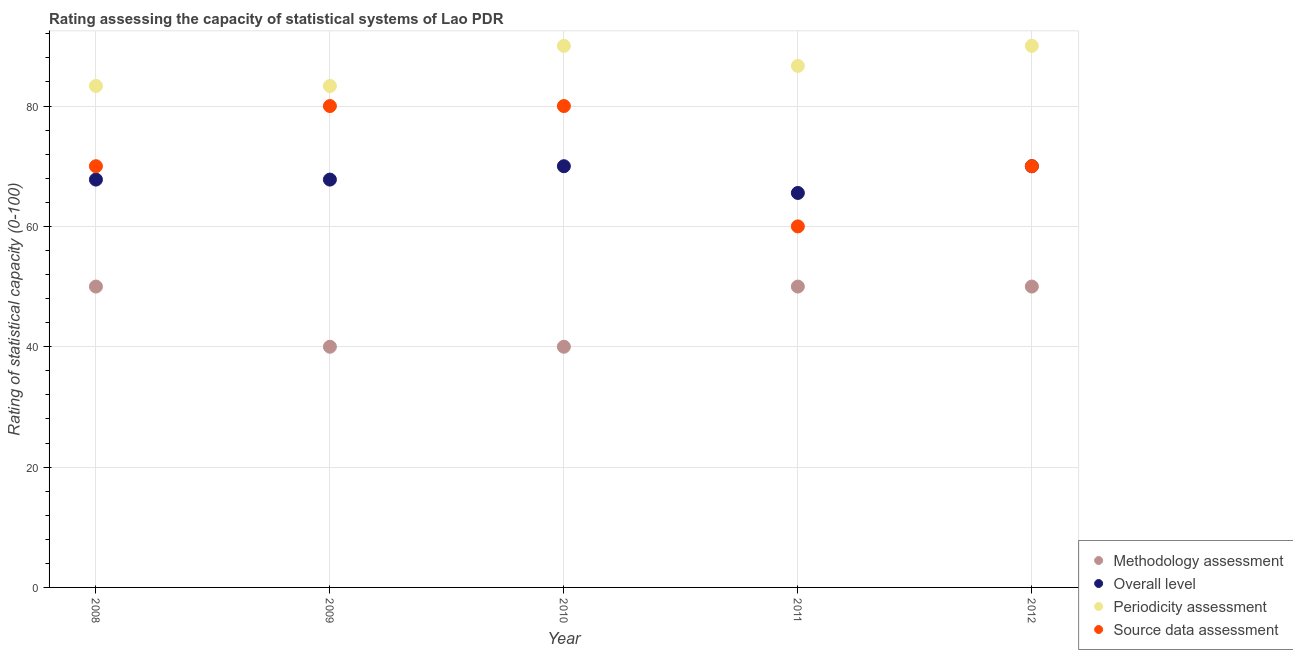How many different coloured dotlines are there?
Your answer should be compact. 4. What is the methodology assessment rating in 2012?
Provide a short and direct response. 50. Across all years, what is the maximum methodology assessment rating?
Provide a short and direct response. 50. Across all years, what is the minimum source data assessment rating?
Make the answer very short. 60. In which year was the periodicity assessment rating maximum?
Keep it short and to the point. 2010. In which year was the source data assessment rating minimum?
Keep it short and to the point. 2011. What is the total source data assessment rating in the graph?
Your answer should be compact. 360. What is the difference between the methodology assessment rating in 2011 and that in 2012?
Keep it short and to the point. 0. What is the average methodology assessment rating per year?
Your answer should be very brief. 46. In the year 2011, what is the difference between the periodicity assessment rating and methodology assessment rating?
Give a very brief answer. 36.67. What is the ratio of the periodicity assessment rating in 2009 to that in 2010?
Offer a terse response. 0.93. What is the difference between the highest and the second highest source data assessment rating?
Offer a very short reply. 0. What is the difference between the highest and the lowest periodicity assessment rating?
Your response must be concise. 6.67. In how many years, is the methodology assessment rating greater than the average methodology assessment rating taken over all years?
Make the answer very short. 3. Is the sum of the periodicity assessment rating in 2009 and 2011 greater than the maximum source data assessment rating across all years?
Offer a very short reply. Yes. Is it the case that in every year, the sum of the periodicity assessment rating and overall level rating is greater than the sum of source data assessment rating and methodology assessment rating?
Keep it short and to the point. No. Is it the case that in every year, the sum of the methodology assessment rating and overall level rating is greater than the periodicity assessment rating?
Give a very brief answer. Yes. Does the overall level rating monotonically increase over the years?
Offer a very short reply. No. Is the source data assessment rating strictly greater than the methodology assessment rating over the years?
Give a very brief answer. Yes. Is the methodology assessment rating strictly less than the overall level rating over the years?
Ensure brevity in your answer.  Yes. How many years are there in the graph?
Your response must be concise. 5. What is the difference between two consecutive major ticks on the Y-axis?
Provide a succinct answer. 20. Does the graph contain any zero values?
Your answer should be very brief. No. Does the graph contain grids?
Your answer should be very brief. Yes. How many legend labels are there?
Give a very brief answer. 4. How are the legend labels stacked?
Your answer should be very brief. Vertical. What is the title of the graph?
Keep it short and to the point. Rating assessing the capacity of statistical systems of Lao PDR. Does "Natural Gas" appear as one of the legend labels in the graph?
Keep it short and to the point. No. What is the label or title of the Y-axis?
Ensure brevity in your answer.  Rating of statistical capacity (0-100). What is the Rating of statistical capacity (0-100) of Methodology assessment in 2008?
Your answer should be compact. 50. What is the Rating of statistical capacity (0-100) of Overall level in 2008?
Provide a short and direct response. 67.78. What is the Rating of statistical capacity (0-100) in Periodicity assessment in 2008?
Keep it short and to the point. 83.33. What is the Rating of statistical capacity (0-100) of Methodology assessment in 2009?
Make the answer very short. 40. What is the Rating of statistical capacity (0-100) of Overall level in 2009?
Offer a terse response. 67.78. What is the Rating of statistical capacity (0-100) of Periodicity assessment in 2009?
Give a very brief answer. 83.33. What is the Rating of statistical capacity (0-100) in Source data assessment in 2009?
Your answer should be compact. 80. What is the Rating of statistical capacity (0-100) of Periodicity assessment in 2010?
Provide a short and direct response. 90. What is the Rating of statistical capacity (0-100) of Source data assessment in 2010?
Your answer should be very brief. 80. What is the Rating of statistical capacity (0-100) in Overall level in 2011?
Make the answer very short. 65.56. What is the Rating of statistical capacity (0-100) in Periodicity assessment in 2011?
Your answer should be very brief. 86.67. What is the Rating of statistical capacity (0-100) of Source data assessment in 2011?
Your answer should be very brief. 60. What is the Rating of statistical capacity (0-100) in Methodology assessment in 2012?
Your response must be concise. 50. What is the Rating of statistical capacity (0-100) of Overall level in 2012?
Give a very brief answer. 70. What is the Rating of statistical capacity (0-100) in Periodicity assessment in 2012?
Provide a short and direct response. 90. Across all years, what is the maximum Rating of statistical capacity (0-100) in Methodology assessment?
Your response must be concise. 50. Across all years, what is the maximum Rating of statistical capacity (0-100) of Overall level?
Your response must be concise. 70. Across all years, what is the maximum Rating of statistical capacity (0-100) in Periodicity assessment?
Provide a succinct answer. 90. Across all years, what is the maximum Rating of statistical capacity (0-100) of Source data assessment?
Make the answer very short. 80. Across all years, what is the minimum Rating of statistical capacity (0-100) of Overall level?
Offer a terse response. 65.56. Across all years, what is the minimum Rating of statistical capacity (0-100) in Periodicity assessment?
Keep it short and to the point. 83.33. What is the total Rating of statistical capacity (0-100) in Methodology assessment in the graph?
Your answer should be compact. 230. What is the total Rating of statistical capacity (0-100) in Overall level in the graph?
Offer a terse response. 341.11. What is the total Rating of statistical capacity (0-100) of Periodicity assessment in the graph?
Offer a very short reply. 433.33. What is the total Rating of statistical capacity (0-100) in Source data assessment in the graph?
Make the answer very short. 360. What is the difference between the Rating of statistical capacity (0-100) of Overall level in 2008 and that in 2009?
Offer a very short reply. 0. What is the difference between the Rating of statistical capacity (0-100) in Periodicity assessment in 2008 and that in 2009?
Provide a succinct answer. 0. What is the difference between the Rating of statistical capacity (0-100) of Methodology assessment in 2008 and that in 2010?
Offer a terse response. 10. What is the difference between the Rating of statistical capacity (0-100) in Overall level in 2008 and that in 2010?
Provide a succinct answer. -2.22. What is the difference between the Rating of statistical capacity (0-100) of Periodicity assessment in 2008 and that in 2010?
Offer a very short reply. -6.67. What is the difference between the Rating of statistical capacity (0-100) of Source data assessment in 2008 and that in 2010?
Provide a succinct answer. -10. What is the difference between the Rating of statistical capacity (0-100) in Methodology assessment in 2008 and that in 2011?
Offer a very short reply. 0. What is the difference between the Rating of statistical capacity (0-100) in Overall level in 2008 and that in 2011?
Provide a succinct answer. 2.22. What is the difference between the Rating of statistical capacity (0-100) of Periodicity assessment in 2008 and that in 2011?
Your response must be concise. -3.33. What is the difference between the Rating of statistical capacity (0-100) of Source data assessment in 2008 and that in 2011?
Your response must be concise. 10. What is the difference between the Rating of statistical capacity (0-100) of Overall level in 2008 and that in 2012?
Your answer should be compact. -2.22. What is the difference between the Rating of statistical capacity (0-100) in Periodicity assessment in 2008 and that in 2012?
Provide a short and direct response. -6.67. What is the difference between the Rating of statistical capacity (0-100) in Methodology assessment in 2009 and that in 2010?
Your response must be concise. 0. What is the difference between the Rating of statistical capacity (0-100) in Overall level in 2009 and that in 2010?
Your response must be concise. -2.22. What is the difference between the Rating of statistical capacity (0-100) in Periodicity assessment in 2009 and that in 2010?
Offer a terse response. -6.67. What is the difference between the Rating of statistical capacity (0-100) of Source data assessment in 2009 and that in 2010?
Your response must be concise. 0. What is the difference between the Rating of statistical capacity (0-100) of Overall level in 2009 and that in 2011?
Offer a very short reply. 2.22. What is the difference between the Rating of statistical capacity (0-100) in Source data assessment in 2009 and that in 2011?
Your response must be concise. 20. What is the difference between the Rating of statistical capacity (0-100) in Methodology assessment in 2009 and that in 2012?
Your answer should be very brief. -10. What is the difference between the Rating of statistical capacity (0-100) of Overall level in 2009 and that in 2012?
Your response must be concise. -2.22. What is the difference between the Rating of statistical capacity (0-100) in Periodicity assessment in 2009 and that in 2012?
Your answer should be very brief. -6.67. What is the difference between the Rating of statistical capacity (0-100) of Source data assessment in 2009 and that in 2012?
Keep it short and to the point. 10. What is the difference between the Rating of statistical capacity (0-100) of Methodology assessment in 2010 and that in 2011?
Provide a short and direct response. -10. What is the difference between the Rating of statistical capacity (0-100) in Overall level in 2010 and that in 2011?
Provide a succinct answer. 4.44. What is the difference between the Rating of statistical capacity (0-100) in Periodicity assessment in 2010 and that in 2011?
Offer a terse response. 3.33. What is the difference between the Rating of statistical capacity (0-100) in Source data assessment in 2010 and that in 2011?
Your answer should be compact. 20. What is the difference between the Rating of statistical capacity (0-100) of Methodology assessment in 2010 and that in 2012?
Make the answer very short. -10. What is the difference between the Rating of statistical capacity (0-100) in Periodicity assessment in 2010 and that in 2012?
Your response must be concise. 0. What is the difference between the Rating of statistical capacity (0-100) of Overall level in 2011 and that in 2012?
Make the answer very short. -4.44. What is the difference between the Rating of statistical capacity (0-100) in Periodicity assessment in 2011 and that in 2012?
Your response must be concise. -3.33. What is the difference between the Rating of statistical capacity (0-100) in Methodology assessment in 2008 and the Rating of statistical capacity (0-100) in Overall level in 2009?
Provide a succinct answer. -17.78. What is the difference between the Rating of statistical capacity (0-100) in Methodology assessment in 2008 and the Rating of statistical capacity (0-100) in Periodicity assessment in 2009?
Ensure brevity in your answer.  -33.33. What is the difference between the Rating of statistical capacity (0-100) of Methodology assessment in 2008 and the Rating of statistical capacity (0-100) of Source data assessment in 2009?
Your answer should be very brief. -30. What is the difference between the Rating of statistical capacity (0-100) in Overall level in 2008 and the Rating of statistical capacity (0-100) in Periodicity assessment in 2009?
Your answer should be compact. -15.56. What is the difference between the Rating of statistical capacity (0-100) in Overall level in 2008 and the Rating of statistical capacity (0-100) in Source data assessment in 2009?
Your answer should be very brief. -12.22. What is the difference between the Rating of statistical capacity (0-100) of Periodicity assessment in 2008 and the Rating of statistical capacity (0-100) of Source data assessment in 2009?
Your response must be concise. 3.33. What is the difference between the Rating of statistical capacity (0-100) in Methodology assessment in 2008 and the Rating of statistical capacity (0-100) in Periodicity assessment in 2010?
Provide a succinct answer. -40. What is the difference between the Rating of statistical capacity (0-100) in Methodology assessment in 2008 and the Rating of statistical capacity (0-100) in Source data assessment in 2010?
Make the answer very short. -30. What is the difference between the Rating of statistical capacity (0-100) of Overall level in 2008 and the Rating of statistical capacity (0-100) of Periodicity assessment in 2010?
Your answer should be compact. -22.22. What is the difference between the Rating of statistical capacity (0-100) in Overall level in 2008 and the Rating of statistical capacity (0-100) in Source data assessment in 2010?
Keep it short and to the point. -12.22. What is the difference between the Rating of statistical capacity (0-100) of Methodology assessment in 2008 and the Rating of statistical capacity (0-100) of Overall level in 2011?
Your response must be concise. -15.56. What is the difference between the Rating of statistical capacity (0-100) of Methodology assessment in 2008 and the Rating of statistical capacity (0-100) of Periodicity assessment in 2011?
Your response must be concise. -36.67. What is the difference between the Rating of statistical capacity (0-100) of Overall level in 2008 and the Rating of statistical capacity (0-100) of Periodicity assessment in 2011?
Your response must be concise. -18.89. What is the difference between the Rating of statistical capacity (0-100) in Overall level in 2008 and the Rating of statistical capacity (0-100) in Source data assessment in 2011?
Your response must be concise. 7.78. What is the difference between the Rating of statistical capacity (0-100) of Periodicity assessment in 2008 and the Rating of statistical capacity (0-100) of Source data assessment in 2011?
Your response must be concise. 23.33. What is the difference between the Rating of statistical capacity (0-100) in Methodology assessment in 2008 and the Rating of statistical capacity (0-100) in Overall level in 2012?
Provide a short and direct response. -20. What is the difference between the Rating of statistical capacity (0-100) of Overall level in 2008 and the Rating of statistical capacity (0-100) of Periodicity assessment in 2012?
Your response must be concise. -22.22. What is the difference between the Rating of statistical capacity (0-100) in Overall level in 2008 and the Rating of statistical capacity (0-100) in Source data assessment in 2012?
Your answer should be compact. -2.22. What is the difference between the Rating of statistical capacity (0-100) of Periodicity assessment in 2008 and the Rating of statistical capacity (0-100) of Source data assessment in 2012?
Offer a very short reply. 13.33. What is the difference between the Rating of statistical capacity (0-100) of Methodology assessment in 2009 and the Rating of statistical capacity (0-100) of Overall level in 2010?
Keep it short and to the point. -30. What is the difference between the Rating of statistical capacity (0-100) of Methodology assessment in 2009 and the Rating of statistical capacity (0-100) of Periodicity assessment in 2010?
Offer a very short reply. -50. What is the difference between the Rating of statistical capacity (0-100) of Overall level in 2009 and the Rating of statistical capacity (0-100) of Periodicity assessment in 2010?
Make the answer very short. -22.22. What is the difference between the Rating of statistical capacity (0-100) of Overall level in 2009 and the Rating of statistical capacity (0-100) of Source data assessment in 2010?
Offer a very short reply. -12.22. What is the difference between the Rating of statistical capacity (0-100) in Methodology assessment in 2009 and the Rating of statistical capacity (0-100) in Overall level in 2011?
Give a very brief answer. -25.56. What is the difference between the Rating of statistical capacity (0-100) in Methodology assessment in 2009 and the Rating of statistical capacity (0-100) in Periodicity assessment in 2011?
Offer a very short reply. -46.67. What is the difference between the Rating of statistical capacity (0-100) in Overall level in 2009 and the Rating of statistical capacity (0-100) in Periodicity assessment in 2011?
Offer a terse response. -18.89. What is the difference between the Rating of statistical capacity (0-100) in Overall level in 2009 and the Rating of statistical capacity (0-100) in Source data assessment in 2011?
Your answer should be very brief. 7.78. What is the difference between the Rating of statistical capacity (0-100) of Periodicity assessment in 2009 and the Rating of statistical capacity (0-100) of Source data assessment in 2011?
Give a very brief answer. 23.33. What is the difference between the Rating of statistical capacity (0-100) in Methodology assessment in 2009 and the Rating of statistical capacity (0-100) in Overall level in 2012?
Keep it short and to the point. -30. What is the difference between the Rating of statistical capacity (0-100) in Methodology assessment in 2009 and the Rating of statistical capacity (0-100) in Source data assessment in 2012?
Make the answer very short. -30. What is the difference between the Rating of statistical capacity (0-100) of Overall level in 2009 and the Rating of statistical capacity (0-100) of Periodicity assessment in 2012?
Your answer should be compact. -22.22. What is the difference between the Rating of statistical capacity (0-100) of Overall level in 2009 and the Rating of statistical capacity (0-100) of Source data assessment in 2012?
Your answer should be very brief. -2.22. What is the difference between the Rating of statistical capacity (0-100) in Periodicity assessment in 2009 and the Rating of statistical capacity (0-100) in Source data assessment in 2012?
Provide a short and direct response. 13.33. What is the difference between the Rating of statistical capacity (0-100) in Methodology assessment in 2010 and the Rating of statistical capacity (0-100) in Overall level in 2011?
Make the answer very short. -25.56. What is the difference between the Rating of statistical capacity (0-100) of Methodology assessment in 2010 and the Rating of statistical capacity (0-100) of Periodicity assessment in 2011?
Keep it short and to the point. -46.67. What is the difference between the Rating of statistical capacity (0-100) in Overall level in 2010 and the Rating of statistical capacity (0-100) in Periodicity assessment in 2011?
Offer a terse response. -16.67. What is the difference between the Rating of statistical capacity (0-100) of Overall level in 2010 and the Rating of statistical capacity (0-100) of Source data assessment in 2011?
Provide a succinct answer. 10. What is the difference between the Rating of statistical capacity (0-100) in Periodicity assessment in 2010 and the Rating of statistical capacity (0-100) in Source data assessment in 2011?
Provide a short and direct response. 30. What is the difference between the Rating of statistical capacity (0-100) of Methodology assessment in 2010 and the Rating of statistical capacity (0-100) of Overall level in 2012?
Give a very brief answer. -30. What is the difference between the Rating of statistical capacity (0-100) of Methodology assessment in 2010 and the Rating of statistical capacity (0-100) of Periodicity assessment in 2012?
Offer a very short reply. -50. What is the difference between the Rating of statistical capacity (0-100) of Methodology assessment in 2010 and the Rating of statistical capacity (0-100) of Source data assessment in 2012?
Keep it short and to the point. -30. What is the difference between the Rating of statistical capacity (0-100) in Overall level in 2010 and the Rating of statistical capacity (0-100) in Source data assessment in 2012?
Offer a terse response. 0. What is the difference between the Rating of statistical capacity (0-100) of Periodicity assessment in 2010 and the Rating of statistical capacity (0-100) of Source data assessment in 2012?
Ensure brevity in your answer.  20. What is the difference between the Rating of statistical capacity (0-100) in Methodology assessment in 2011 and the Rating of statistical capacity (0-100) in Source data assessment in 2012?
Make the answer very short. -20. What is the difference between the Rating of statistical capacity (0-100) of Overall level in 2011 and the Rating of statistical capacity (0-100) of Periodicity assessment in 2012?
Keep it short and to the point. -24.44. What is the difference between the Rating of statistical capacity (0-100) in Overall level in 2011 and the Rating of statistical capacity (0-100) in Source data assessment in 2012?
Give a very brief answer. -4.44. What is the difference between the Rating of statistical capacity (0-100) of Periodicity assessment in 2011 and the Rating of statistical capacity (0-100) of Source data assessment in 2012?
Provide a succinct answer. 16.67. What is the average Rating of statistical capacity (0-100) in Methodology assessment per year?
Give a very brief answer. 46. What is the average Rating of statistical capacity (0-100) of Overall level per year?
Give a very brief answer. 68.22. What is the average Rating of statistical capacity (0-100) in Periodicity assessment per year?
Give a very brief answer. 86.67. In the year 2008, what is the difference between the Rating of statistical capacity (0-100) of Methodology assessment and Rating of statistical capacity (0-100) of Overall level?
Your response must be concise. -17.78. In the year 2008, what is the difference between the Rating of statistical capacity (0-100) in Methodology assessment and Rating of statistical capacity (0-100) in Periodicity assessment?
Make the answer very short. -33.33. In the year 2008, what is the difference between the Rating of statistical capacity (0-100) of Overall level and Rating of statistical capacity (0-100) of Periodicity assessment?
Your answer should be compact. -15.56. In the year 2008, what is the difference between the Rating of statistical capacity (0-100) of Overall level and Rating of statistical capacity (0-100) of Source data assessment?
Keep it short and to the point. -2.22. In the year 2008, what is the difference between the Rating of statistical capacity (0-100) of Periodicity assessment and Rating of statistical capacity (0-100) of Source data assessment?
Your response must be concise. 13.33. In the year 2009, what is the difference between the Rating of statistical capacity (0-100) of Methodology assessment and Rating of statistical capacity (0-100) of Overall level?
Provide a short and direct response. -27.78. In the year 2009, what is the difference between the Rating of statistical capacity (0-100) of Methodology assessment and Rating of statistical capacity (0-100) of Periodicity assessment?
Provide a short and direct response. -43.33. In the year 2009, what is the difference between the Rating of statistical capacity (0-100) of Methodology assessment and Rating of statistical capacity (0-100) of Source data assessment?
Provide a succinct answer. -40. In the year 2009, what is the difference between the Rating of statistical capacity (0-100) of Overall level and Rating of statistical capacity (0-100) of Periodicity assessment?
Provide a succinct answer. -15.56. In the year 2009, what is the difference between the Rating of statistical capacity (0-100) of Overall level and Rating of statistical capacity (0-100) of Source data assessment?
Your response must be concise. -12.22. In the year 2010, what is the difference between the Rating of statistical capacity (0-100) of Methodology assessment and Rating of statistical capacity (0-100) of Overall level?
Offer a terse response. -30. In the year 2010, what is the difference between the Rating of statistical capacity (0-100) of Methodology assessment and Rating of statistical capacity (0-100) of Periodicity assessment?
Your answer should be very brief. -50. In the year 2010, what is the difference between the Rating of statistical capacity (0-100) of Periodicity assessment and Rating of statistical capacity (0-100) of Source data assessment?
Keep it short and to the point. 10. In the year 2011, what is the difference between the Rating of statistical capacity (0-100) of Methodology assessment and Rating of statistical capacity (0-100) of Overall level?
Your answer should be compact. -15.56. In the year 2011, what is the difference between the Rating of statistical capacity (0-100) in Methodology assessment and Rating of statistical capacity (0-100) in Periodicity assessment?
Ensure brevity in your answer.  -36.67. In the year 2011, what is the difference between the Rating of statistical capacity (0-100) of Overall level and Rating of statistical capacity (0-100) of Periodicity assessment?
Your answer should be compact. -21.11. In the year 2011, what is the difference between the Rating of statistical capacity (0-100) in Overall level and Rating of statistical capacity (0-100) in Source data assessment?
Your answer should be compact. 5.56. In the year 2011, what is the difference between the Rating of statistical capacity (0-100) of Periodicity assessment and Rating of statistical capacity (0-100) of Source data assessment?
Provide a short and direct response. 26.67. In the year 2012, what is the difference between the Rating of statistical capacity (0-100) in Methodology assessment and Rating of statistical capacity (0-100) in Overall level?
Your answer should be compact. -20. In the year 2012, what is the difference between the Rating of statistical capacity (0-100) in Methodology assessment and Rating of statistical capacity (0-100) in Periodicity assessment?
Ensure brevity in your answer.  -40. In the year 2012, what is the difference between the Rating of statistical capacity (0-100) of Overall level and Rating of statistical capacity (0-100) of Source data assessment?
Your response must be concise. 0. In the year 2012, what is the difference between the Rating of statistical capacity (0-100) in Periodicity assessment and Rating of statistical capacity (0-100) in Source data assessment?
Offer a very short reply. 20. What is the ratio of the Rating of statistical capacity (0-100) in Overall level in 2008 to that in 2009?
Provide a succinct answer. 1. What is the ratio of the Rating of statistical capacity (0-100) in Methodology assessment in 2008 to that in 2010?
Offer a very short reply. 1.25. What is the ratio of the Rating of statistical capacity (0-100) of Overall level in 2008 to that in 2010?
Provide a succinct answer. 0.97. What is the ratio of the Rating of statistical capacity (0-100) of Periodicity assessment in 2008 to that in 2010?
Provide a short and direct response. 0.93. What is the ratio of the Rating of statistical capacity (0-100) of Source data assessment in 2008 to that in 2010?
Your answer should be very brief. 0.88. What is the ratio of the Rating of statistical capacity (0-100) of Methodology assessment in 2008 to that in 2011?
Provide a succinct answer. 1. What is the ratio of the Rating of statistical capacity (0-100) of Overall level in 2008 to that in 2011?
Give a very brief answer. 1.03. What is the ratio of the Rating of statistical capacity (0-100) in Periodicity assessment in 2008 to that in 2011?
Offer a terse response. 0.96. What is the ratio of the Rating of statistical capacity (0-100) in Source data assessment in 2008 to that in 2011?
Provide a succinct answer. 1.17. What is the ratio of the Rating of statistical capacity (0-100) of Methodology assessment in 2008 to that in 2012?
Offer a very short reply. 1. What is the ratio of the Rating of statistical capacity (0-100) of Overall level in 2008 to that in 2012?
Keep it short and to the point. 0.97. What is the ratio of the Rating of statistical capacity (0-100) in Periodicity assessment in 2008 to that in 2012?
Provide a succinct answer. 0.93. What is the ratio of the Rating of statistical capacity (0-100) in Source data assessment in 2008 to that in 2012?
Your answer should be compact. 1. What is the ratio of the Rating of statistical capacity (0-100) of Overall level in 2009 to that in 2010?
Offer a very short reply. 0.97. What is the ratio of the Rating of statistical capacity (0-100) in Periodicity assessment in 2009 to that in 2010?
Keep it short and to the point. 0.93. What is the ratio of the Rating of statistical capacity (0-100) of Overall level in 2009 to that in 2011?
Make the answer very short. 1.03. What is the ratio of the Rating of statistical capacity (0-100) in Periodicity assessment in 2009 to that in 2011?
Offer a terse response. 0.96. What is the ratio of the Rating of statistical capacity (0-100) in Source data assessment in 2009 to that in 2011?
Offer a terse response. 1.33. What is the ratio of the Rating of statistical capacity (0-100) of Methodology assessment in 2009 to that in 2012?
Offer a very short reply. 0.8. What is the ratio of the Rating of statistical capacity (0-100) of Overall level in 2009 to that in 2012?
Offer a very short reply. 0.97. What is the ratio of the Rating of statistical capacity (0-100) of Periodicity assessment in 2009 to that in 2012?
Your answer should be compact. 0.93. What is the ratio of the Rating of statistical capacity (0-100) of Source data assessment in 2009 to that in 2012?
Provide a succinct answer. 1.14. What is the ratio of the Rating of statistical capacity (0-100) in Methodology assessment in 2010 to that in 2011?
Offer a very short reply. 0.8. What is the ratio of the Rating of statistical capacity (0-100) of Overall level in 2010 to that in 2011?
Provide a succinct answer. 1.07. What is the ratio of the Rating of statistical capacity (0-100) in Periodicity assessment in 2010 to that in 2011?
Give a very brief answer. 1.04. What is the ratio of the Rating of statistical capacity (0-100) in Overall level in 2010 to that in 2012?
Offer a terse response. 1. What is the ratio of the Rating of statistical capacity (0-100) of Periodicity assessment in 2010 to that in 2012?
Provide a short and direct response. 1. What is the ratio of the Rating of statistical capacity (0-100) of Methodology assessment in 2011 to that in 2012?
Provide a succinct answer. 1. What is the ratio of the Rating of statistical capacity (0-100) of Overall level in 2011 to that in 2012?
Ensure brevity in your answer.  0.94. What is the ratio of the Rating of statistical capacity (0-100) of Source data assessment in 2011 to that in 2012?
Offer a terse response. 0.86. What is the difference between the highest and the second highest Rating of statistical capacity (0-100) in Methodology assessment?
Provide a short and direct response. 0. What is the difference between the highest and the second highest Rating of statistical capacity (0-100) in Overall level?
Keep it short and to the point. 0. What is the difference between the highest and the second highest Rating of statistical capacity (0-100) in Periodicity assessment?
Provide a succinct answer. 0. What is the difference between the highest and the second highest Rating of statistical capacity (0-100) in Source data assessment?
Your response must be concise. 0. What is the difference between the highest and the lowest Rating of statistical capacity (0-100) in Overall level?
Keep it short and to the point. 4.44. 